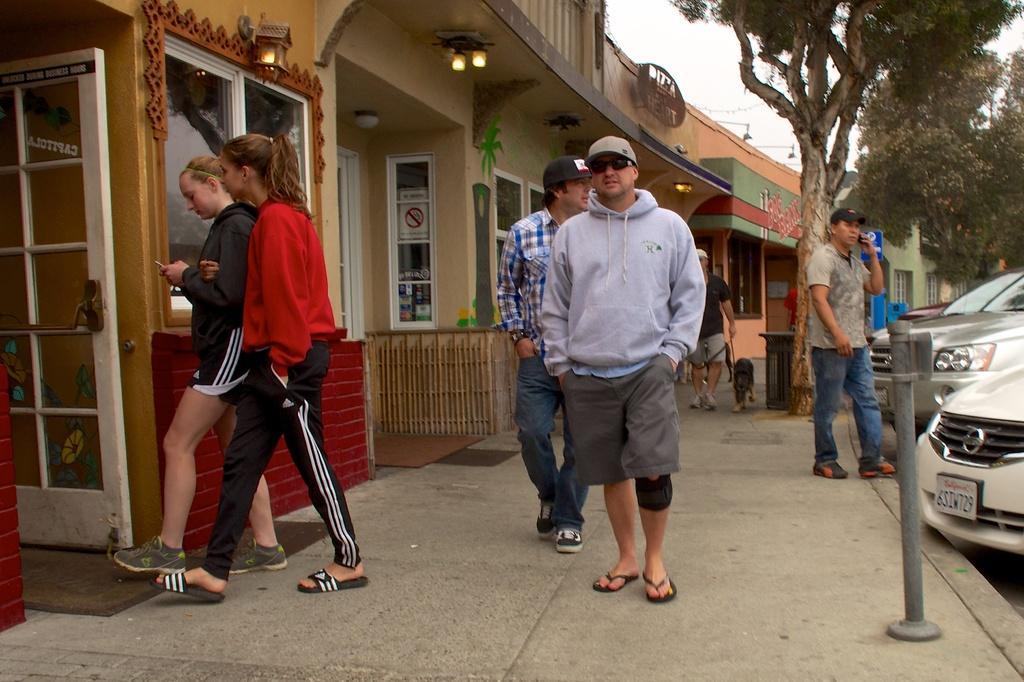Can you describe this image briefly? In the image there are few people on the path and on the left side there are some stores, in the background there are trees and on the right side there are cars. 